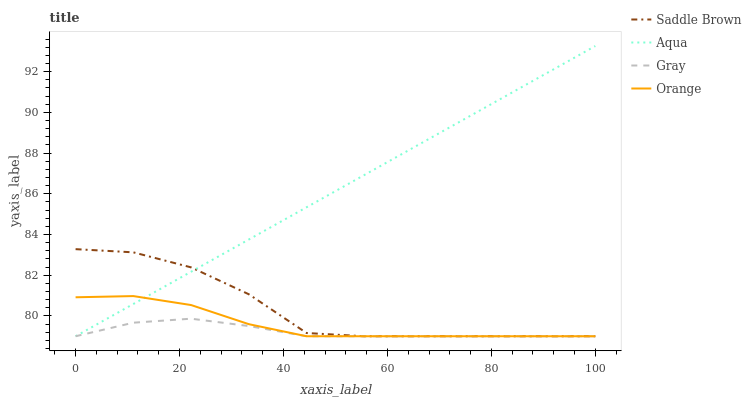Does Gray have the minimum area under the curve?
Answer yes or no. Yes. Does Aqua have the maximum area under the curve?
Answer yes or no. Yes. Does Aqua have the minimum area under the curve?
Answer yes or no. No. Does Gray have the maximum area under the curve?
Answer yes or no. No. Is Aqua the smoothest?
Answer yes or no. Yes. Is Saddle Brown the roughest?
Answer yes or no. Yes. Is Gray the smoothest?
Answer yes or no. No. Is Gray the roughest?
Answer yes or no. No. Does Orange have the lowest value?
Answer yes or no. Yes. Does Aqua have the highest value?
Answer yes or no. Yes. Does Gray have the highest value?
Answer yes or no. No. Does Aqua intersect Orange?
Answer yes or no. Yes. Is Aqua less than Orange?
Answer yes or no. No. Is Aqua greater than Orange?
Answer yes or no. No. 